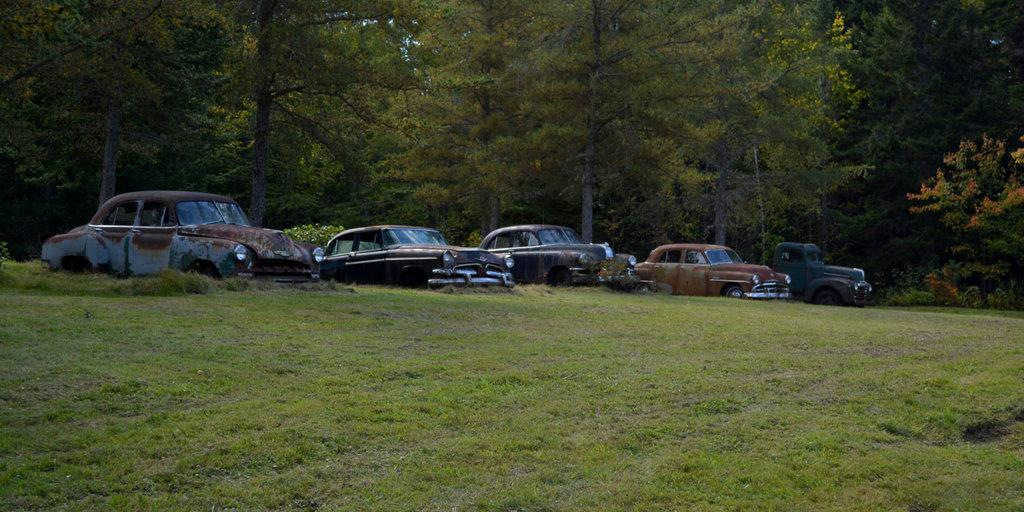What can be seen in the background of the image? There are cars and trees in the background of the image. What type of vegetation is visible at the bottom of the image? There is grass at the bottom of the image. What type of bulb is used to illuminate the cars in the image? There is no mention of any bulbs or illumination in the image; it only shows cars and trees in the background. How does the friction between the grass and the tires of the cars affect the image? The image does not depict any movement or interaction between the grass and the cars, so it is not possible to determine the effect of friction. 